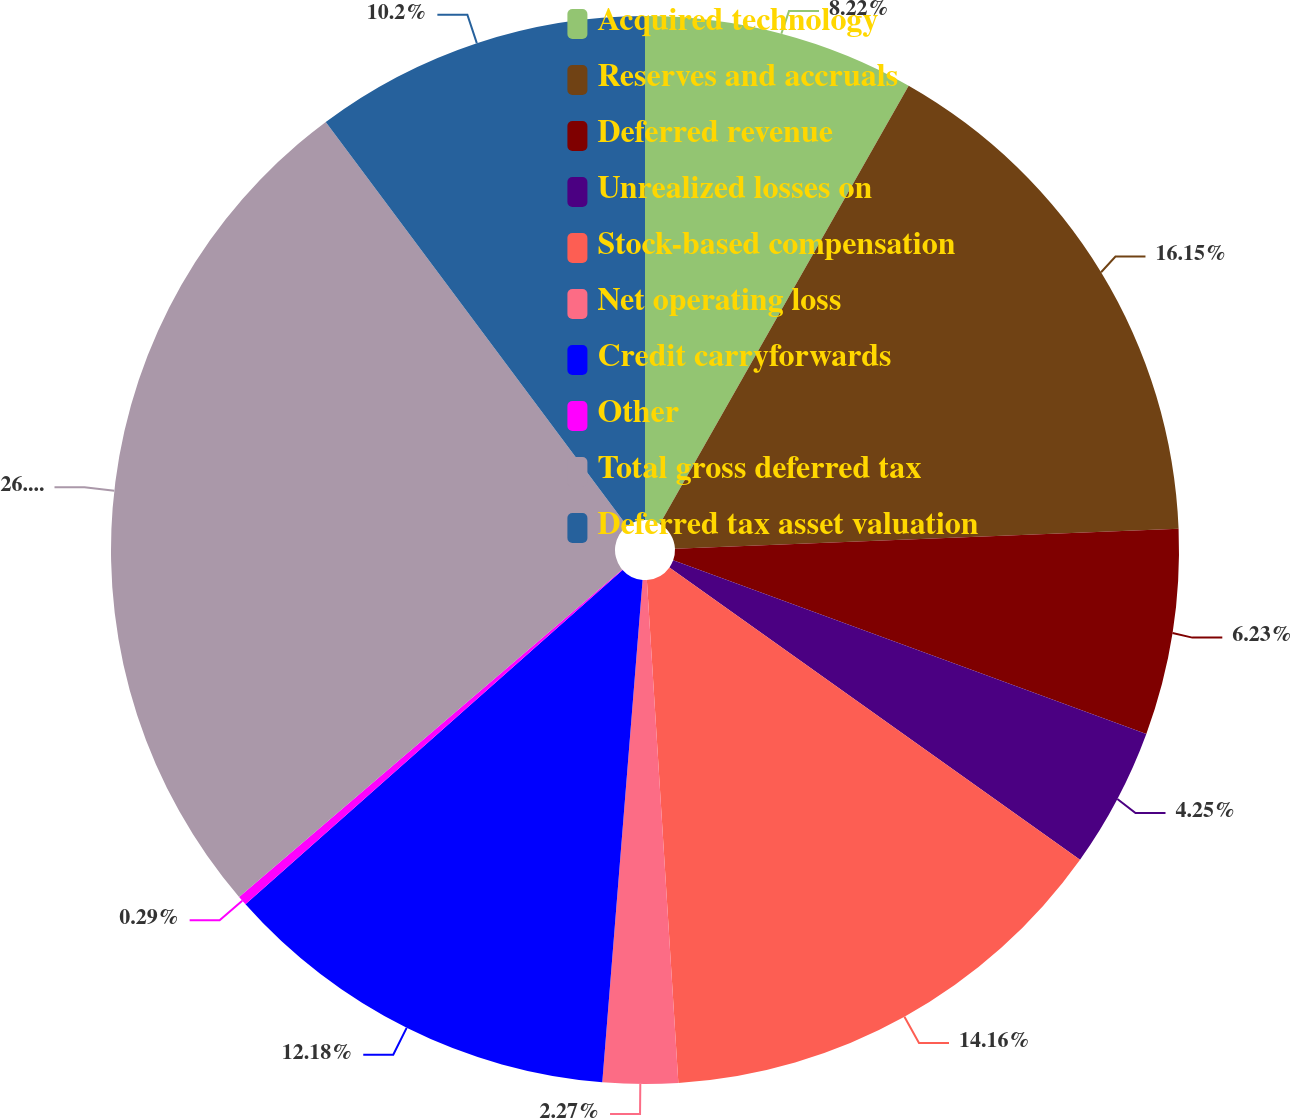Convert chart. <chart><loc_0><loc_0><loc_500><loc_500><pie_chart><fcel>Acquired technology<fcel>Reserves and accruals<fcel>Deferred revenue<fcel>Unrealized losses on<fcel>Stock-based compensation<fcel>Net operating loss<fcel>Credit carryforwards<fcel>Other<fcel>Total gross deferred tax<fcel>Deferred tax asset valuation<nl><fcel>8.22%<fcel>16.15%<fcel>6.23%<fcel>4.25%<fcel>14.16%<fcel>2.27%<fcel>12.18%<fcel>0.29%<fcel>26.06%<fcel>10.2%<nl></chart> 